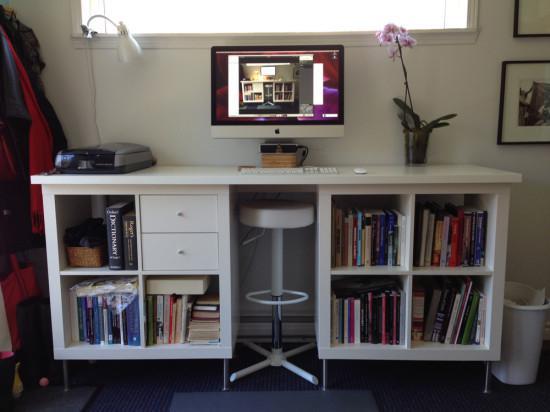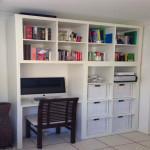The first image is the image on the left, the second image is the image on the right. Examine the images to the left and right. Is the description "There is a four legged chair at each of the white desk areas." accurate? Answer yes or no. No. The first image is the image on the left, the second image is the image on the right. For the images displayed, is the sentence "One bookcase nearly fills a wall and has a counter in the center flanked by at least two rows of shelves and two cabinets on either side." factually correct? Answer yes or no. No. 